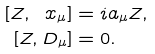Convert formula to latex. <formula><loc_0><loc_0><loc_500><loc_500>[ Z , \ x _ { \mu } ] & = i a _ { \mu } Z , \\ [ Z , D _ { \mu } ] & = 0 .</formula> 